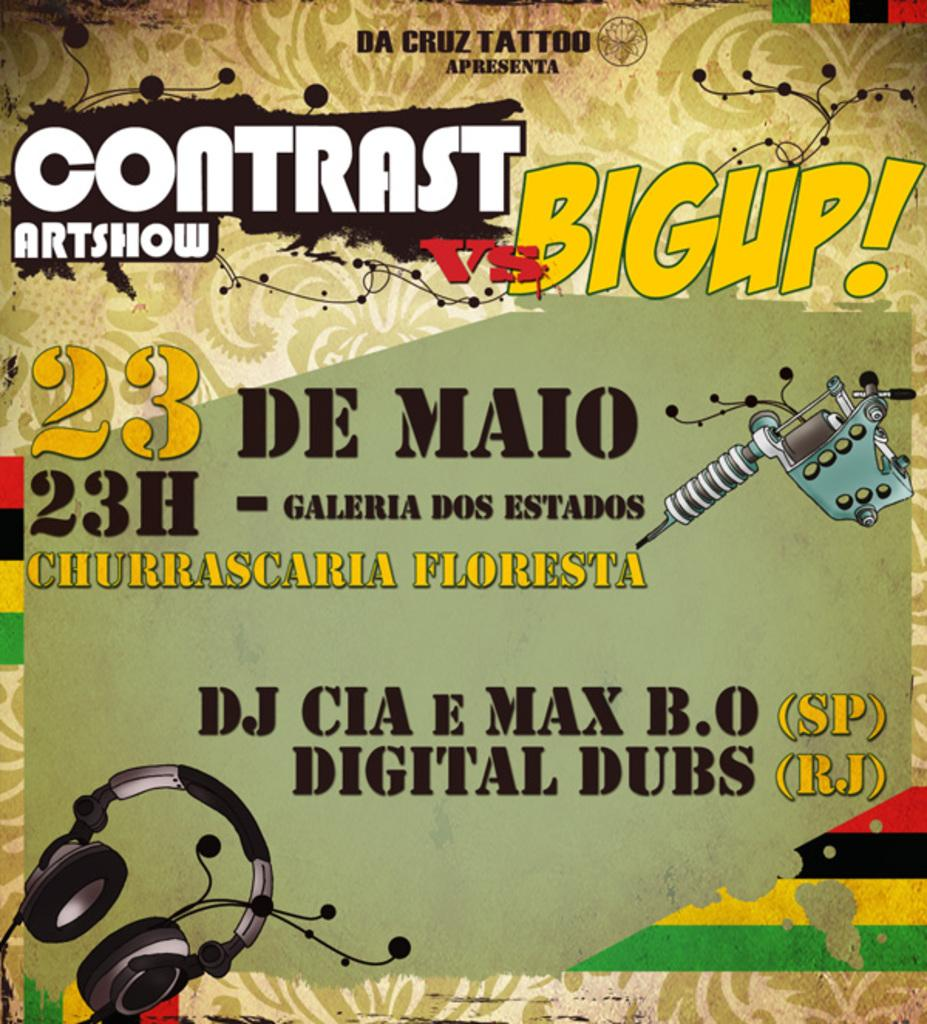<image>
Describe the image concisely. a flyer that says 'contrast artshow vs bigup! 